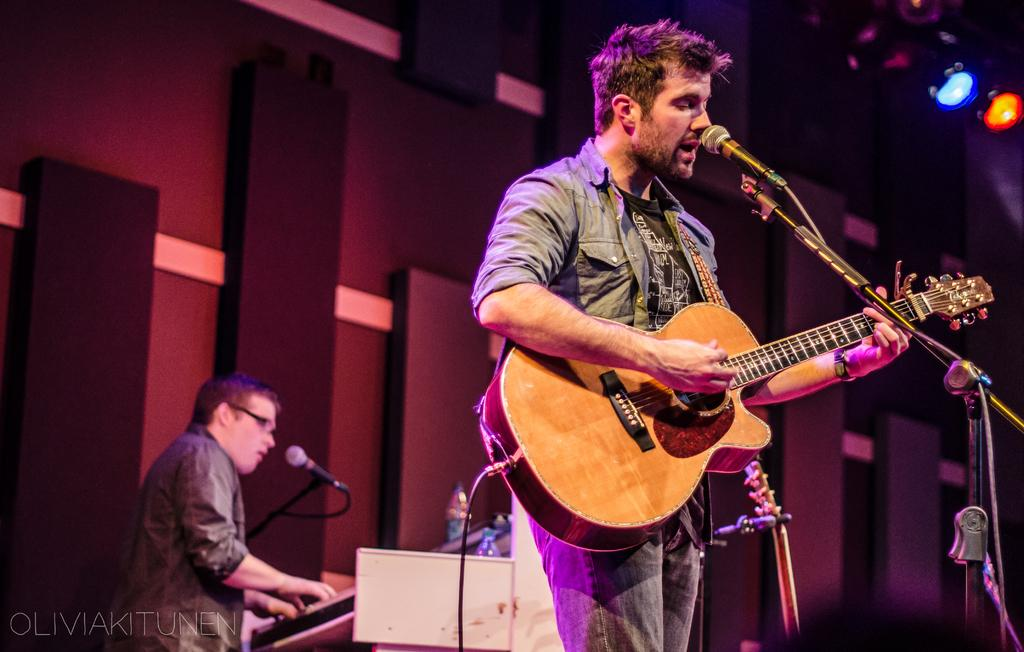What is the man in the image holding? The man is holding a guitar in his hand. Can you describe the other person in the image? The other person is playing a musical instrument. What are the two people in the image doing? The man is holding a guitar, and the other person is playing a musical instrument, which suggests they might be playing music together. What date is circled on the calendar in the image? There is no calendar present in the image. How can the man in the image help the person who needs assistance? The image does not show any indication of someone needing help, nor does it provide any information about the man's ability to help. 